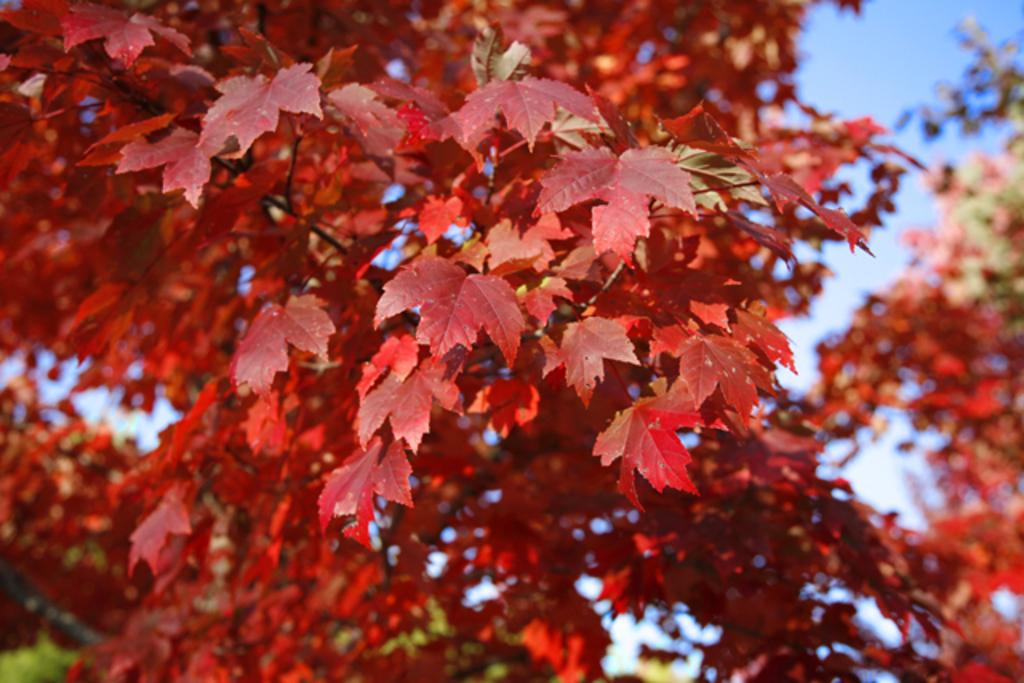What is the main subject of the picture? The main subject of the picture is a tree. What type of leaves are on the tree? The tree has maple leaves. What color are the maple leaves? The maple leaves are red in color. Are there any other types of leaves on the tree? Yes, there are other leaves on the tree. What can be seen in the background of the picture? The sky is visible in the background of the picture. What type of body is visible in the image? There is no body present in the image; it features a tree with leaves. Is the image taken during the night? The image does not indicate whether it was taken during the night or day, but the presence of the sky suggests it was taken during daylight. 